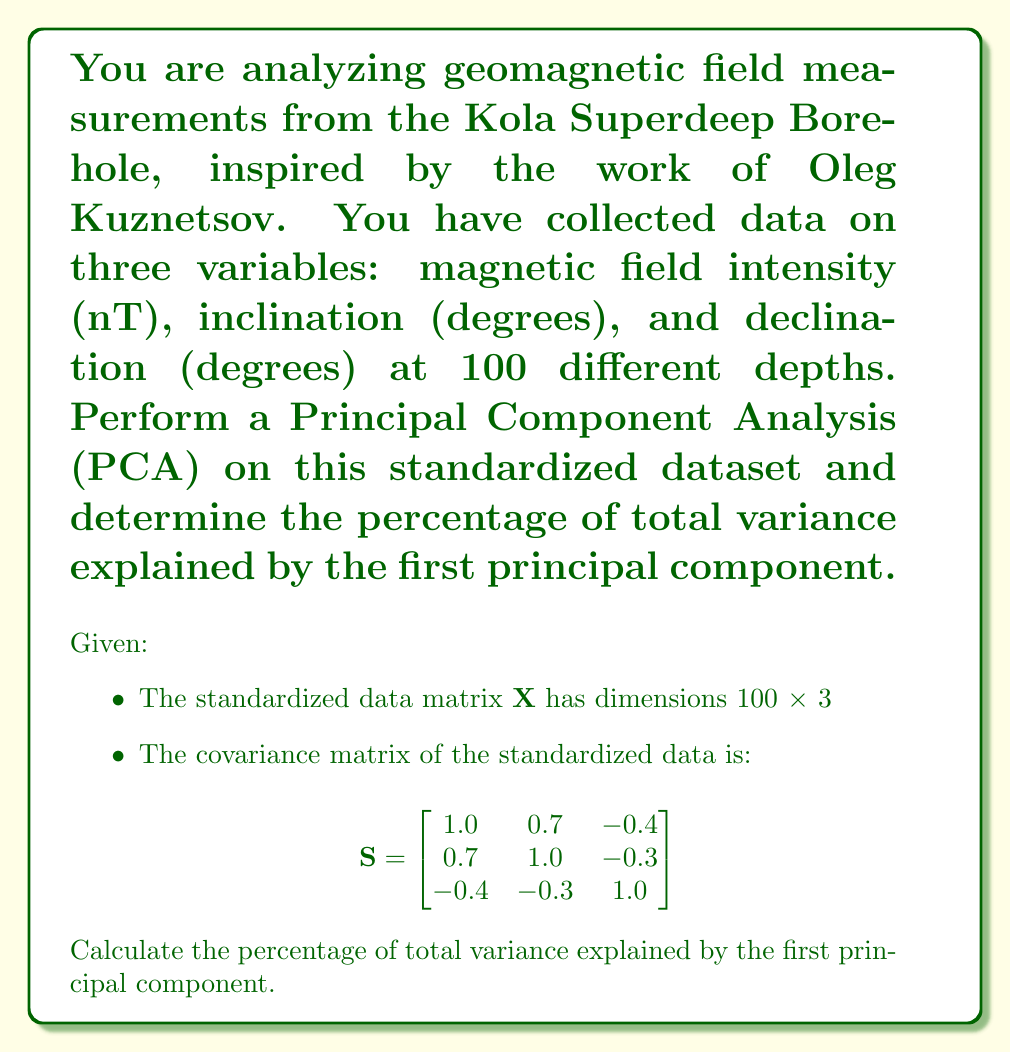Solve this math problem. Let's approach this step-by-step:

1) In PCA, we need to find the eigenvalues and eigenvectors of the covariance matrix $\mathbf{S}$.

2) The characteristic equation is:
   $$\det(\mathbf{S} - \lambda\mathbf{I}) = 0$$

3) Expanding this:
   $$(1-\lambda)(1-\lambda)(1-\lambda) - 0.7^2(1-\lambda) - 0.4^2(1-\lambda) - 0.3^2(1-\lambda) + 2(0.7)(-0.4)(-0.3) = 0$$

4) Simplifying:
   $$-\lambda^3 + 3\lambda^2 - 2.02\lambda + 0.168 = 0$$

5) Solving this cubic equation (using a calculator or computer algebra system), we get the eigenvalues:
   $$\lambda_1 \approx 2.0599, \lambda_2 \approx 0.8084, \lambda_3 \approx 0.1317$$

6) The total variance is the sum of these eigenvalues:
   $$\text{Total Variance} = 2.0599 + 0.8084 + 0.1317 = 3$$

7) The first principal component corresponds to the largest eigenvalue, $\lambda_1 \approx 2.0599$.

8) The percentage of total variance explained by the first principal component is:
   $$\frac{\lambda_1}{\text{Total Variance}} \times 100\% = \frac{2.0599}{3} \times 100\% \approx 68.66\%$$
Answer: 68.66% 